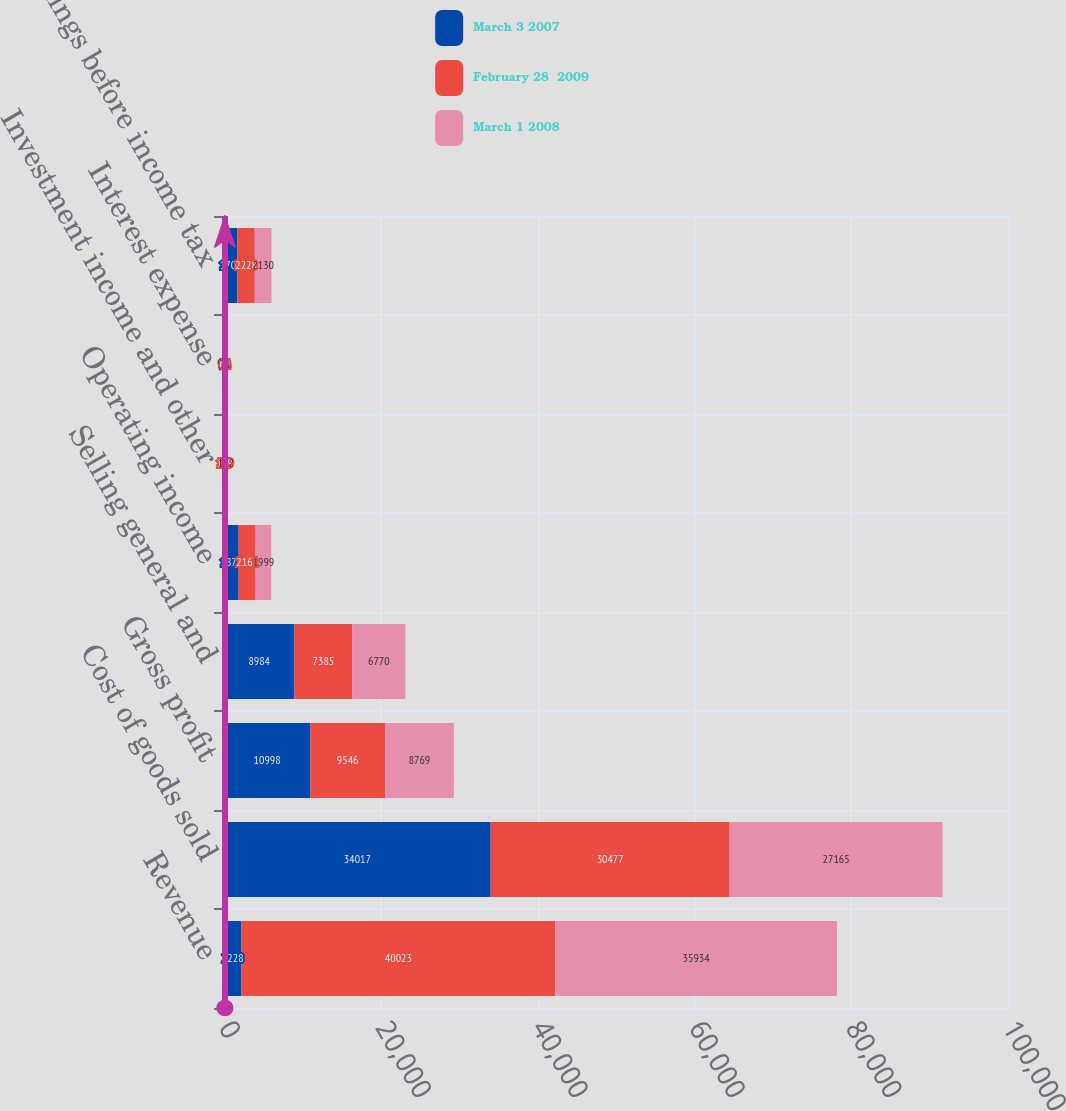<chart> <loc_0><loc_0><loc_500><loc_500><stacked_bar_chart><ecel><fcel>Revenue<fcel>Cost of goods sold<fcel>Gross profit<fcel>Selling general and<fcel>Operating income<fcel>Investment income and other<fcel>Interest expense<fcel>Earnings before income tax<nl><fcel>March 3 2007<fcel>2228<fcel>34017<fcel>10998<fcel>8984<fcel>1870<fcel>35<fcel>94<fcel>1700<nl><fcel>February 28  2009<fcel>40023<fcel>30477<fcel>9546<fcel>7385<fcel>2161<fcel>129<fcel>62<fcel>2228<nl><fcel>March 1 2008<fcel>35934<fcel>27165<fcel>8769<fcel>6770<fcel>1999<fcel>162<fcel>31<fcel>2130<nl></chart> 